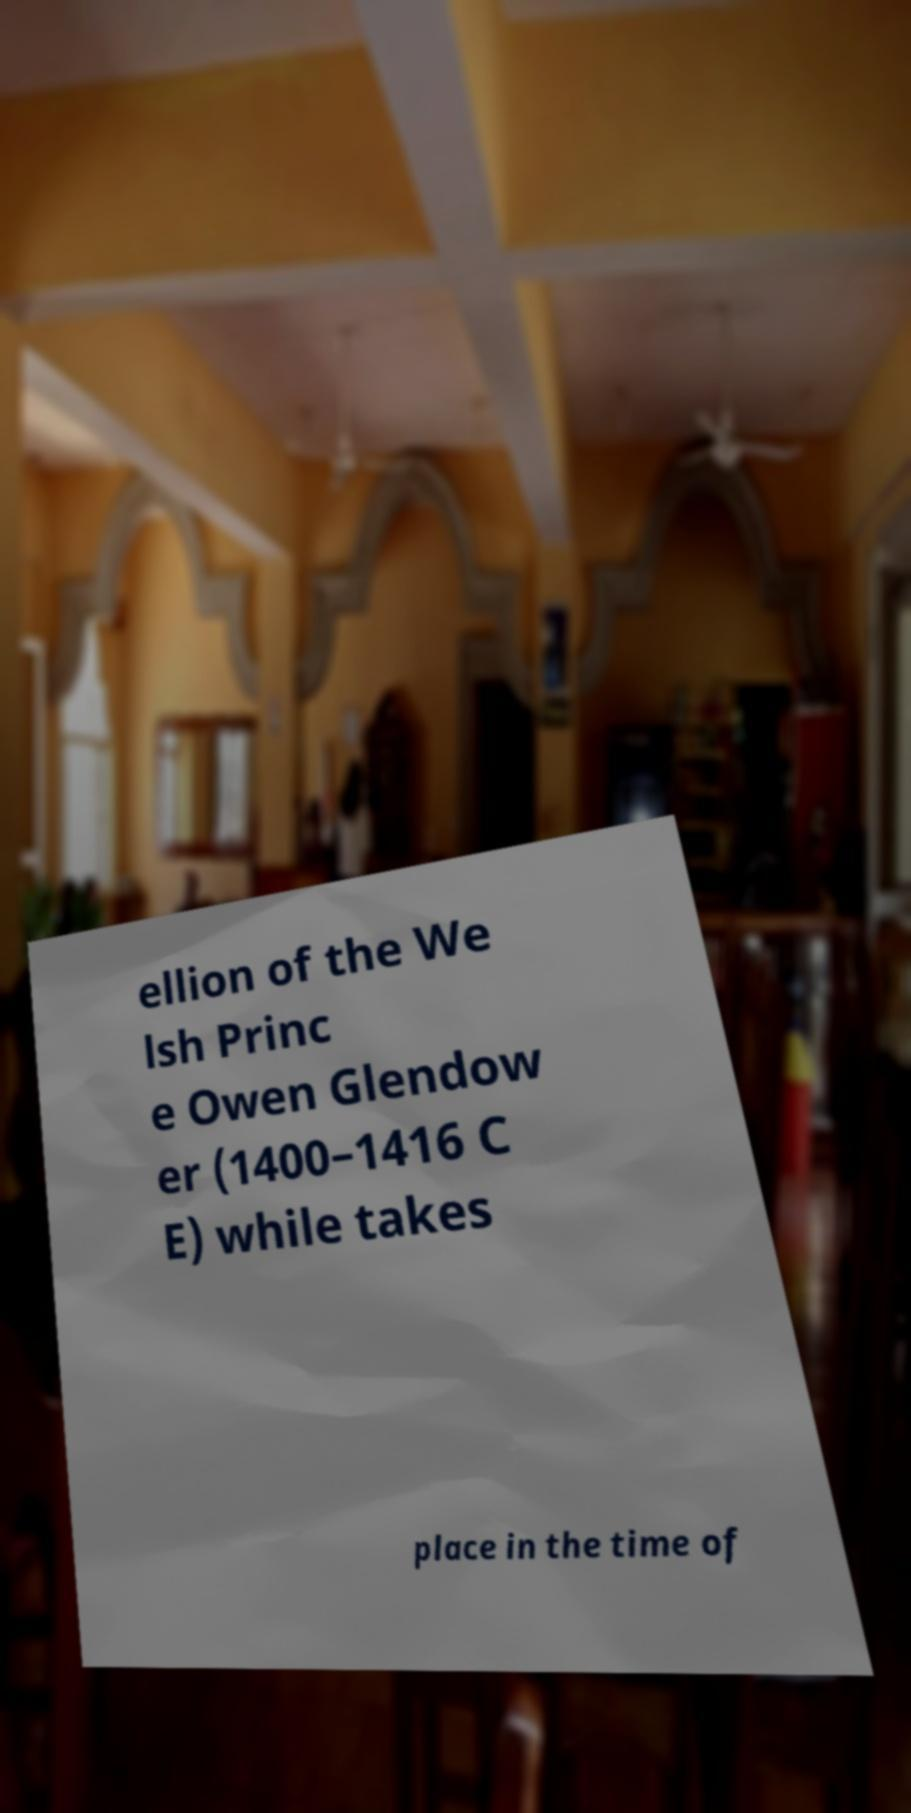What messages or text are displayed in this image? I need them in a readable, typed format. ellion of the We lsh Princ e Owen Glendow er (1400–1416 C E) while takes place in the time of 